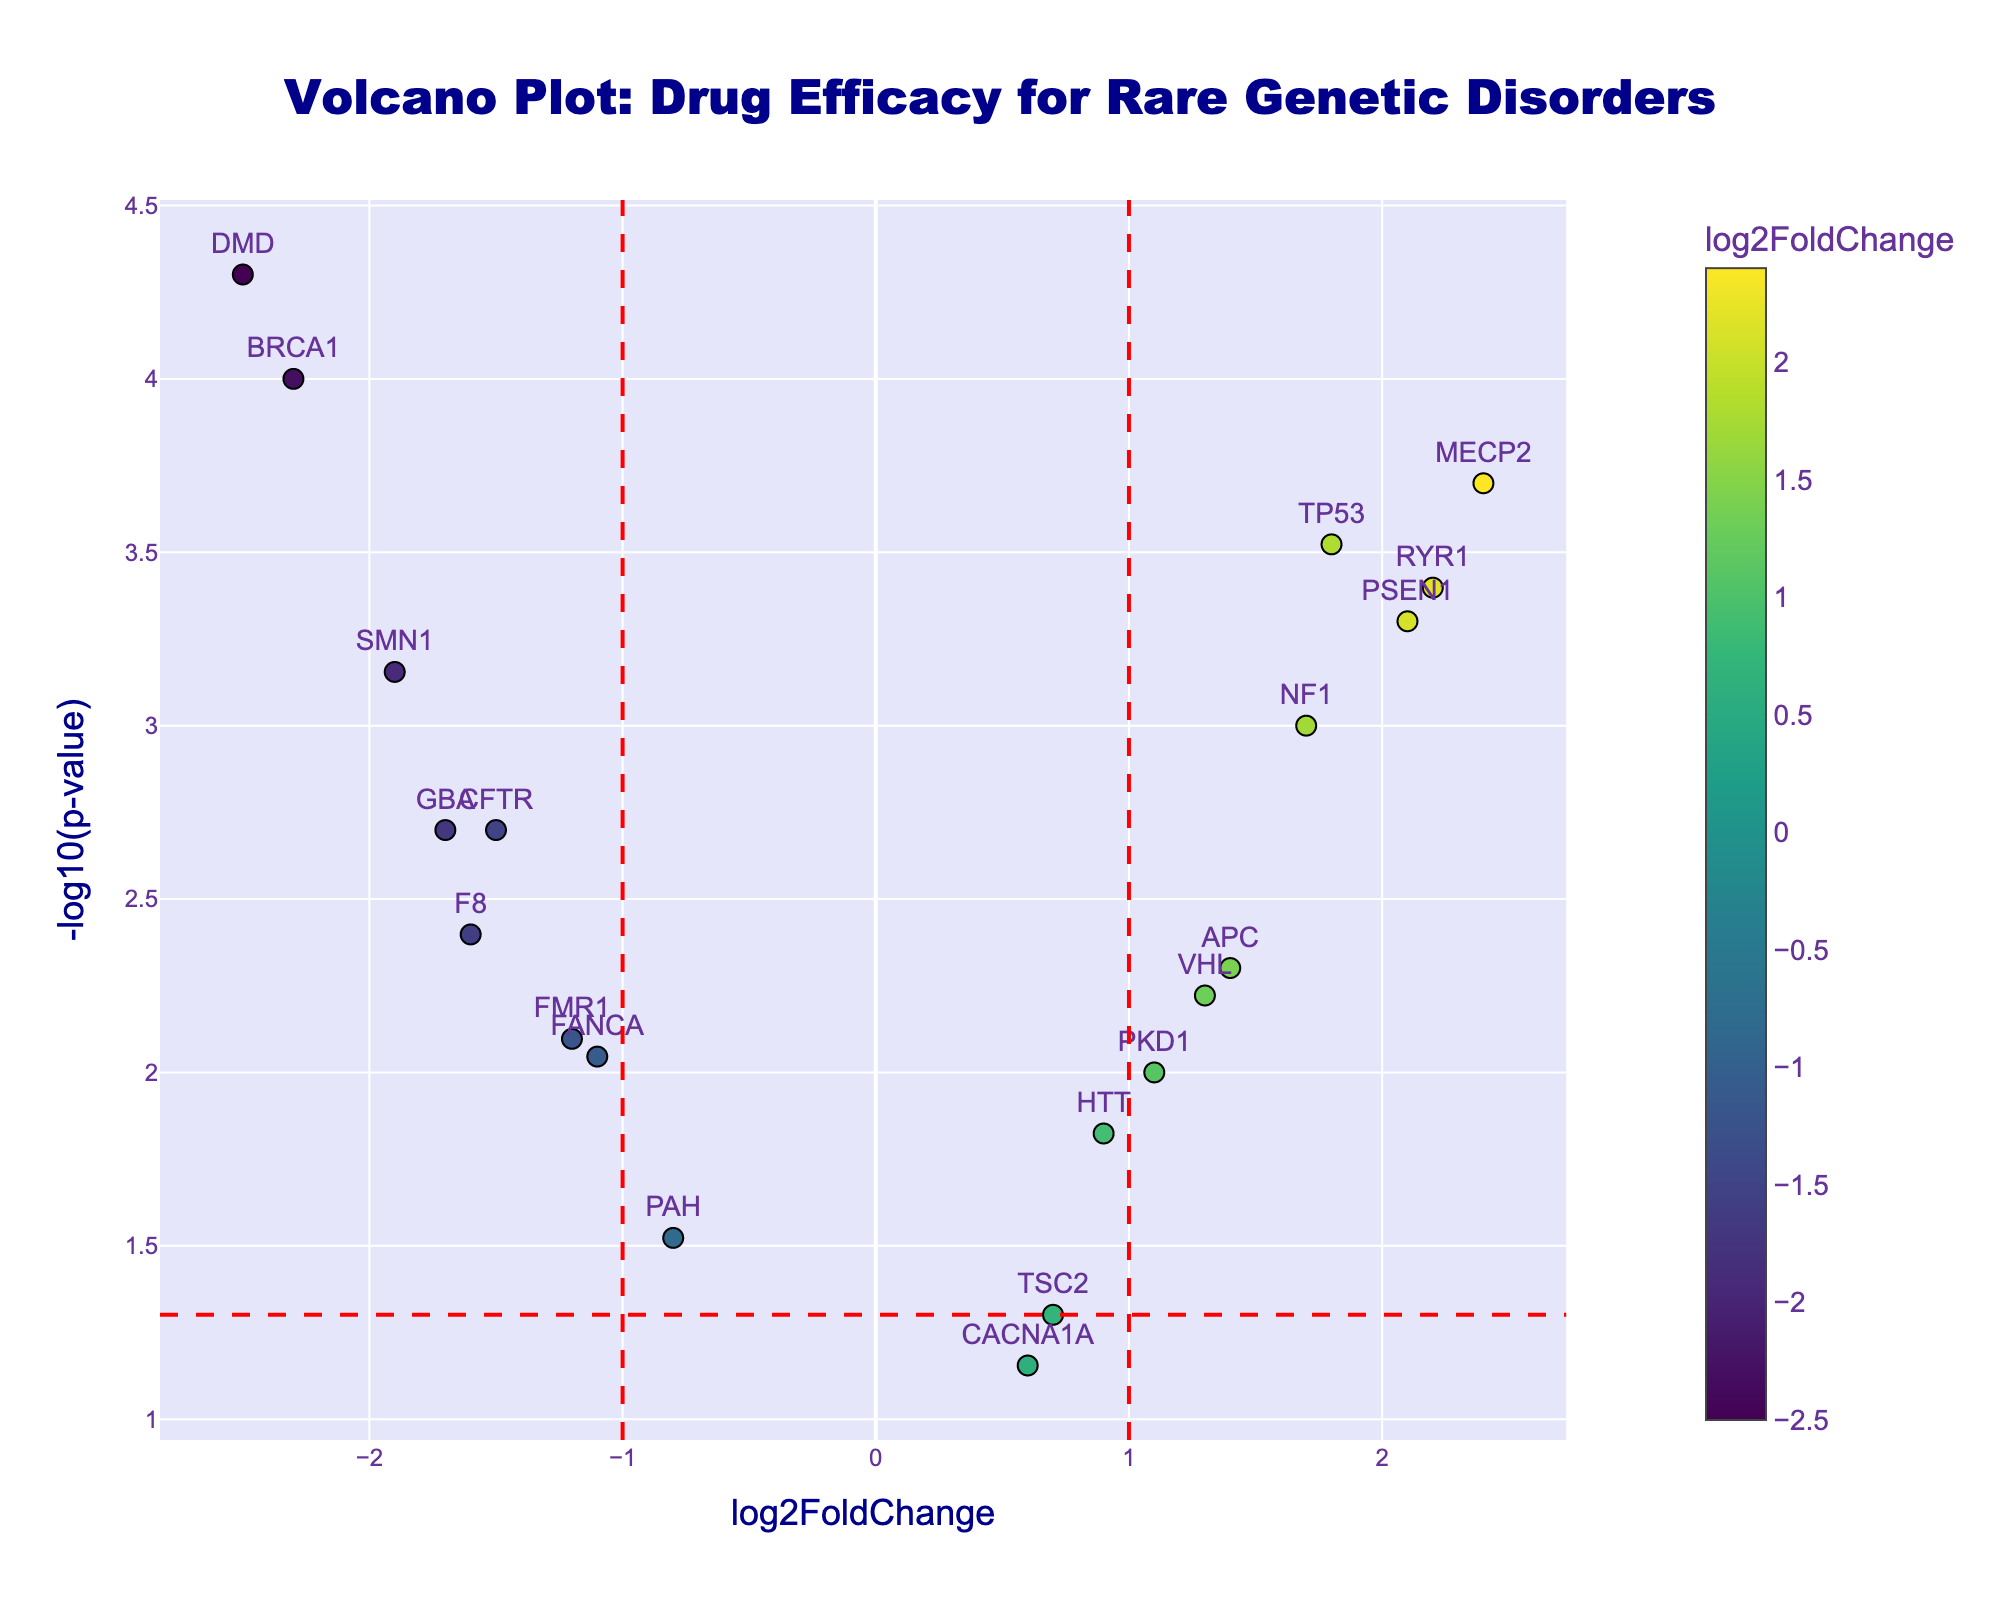What is the title of the plot? The title is typically found at the top of the plot in a larger font. For this plot, the title is centered at the top, and it reads "Volcano Plot: Drug Efficacy for Rare Genetic Disorders".
Answer: Volcano Plot: Drug Efficacy for Rare Genetic Disorders What is the x-axis representing? To understand what the x-axis represents, look at the label on the x-axis. In this plot, the x-axis label is "log2FoldChange", indicating it represents the log2-transformed fold change of drug efficacy.
Answer: log2FoldChange How many genes have a negative log2FoldChange? To determine how many genes have a negative log2FoldChange, count the data points on the left side of the y-axis (where log2FoldChange < 0). These genes include BRCA1, CFTR, FMR1, DMD, PAH, SMN1, F8, FANCA, and GBA.
Answer: 9 What is the y-axis value for the gene with the highest log2FoldChange? Locate the gene with the highest log2FoldChange on the x-axis, which is MECP2 with a log2FoldChange of 2.4. Then, check its corresponding y-axis value, which is -log10(p-value) calculated from the p-value (0.0002). -log10(0.0002) approximately equals 3.70.
Answer: 3.70 Which gene has the smallest p-value? The smallest p-value can be found by looking at the highest point on the y-axis, as -log10(p-value) will be the largest for the smallest p-value. The highest point corresponds to the gene DMD.
Answer: DMD How many genes are considered significantly different in their drug efficacy with a threshold of p-value < 0.05 and log2FoldChange >1 or < -1? Identify the genes that meet both criteria: p-value < 0.05, and log2FoldChange > 1 or < -1. This includes BRCA1, TP53, PSEN1, DMD, NF1, MECP2, SMN1, RYR1, and GBA.
Answer: 9 Which gene shows the highest negative log2FoldChange? The highest negative log2FoldChange is found by locating the leftmost point on the x-axis. This point corresponds to DMD with a log2FoldChange of -2.5.
Answer: DMD Which gene has the highest p-value, appearing closest to the x-axis? The gene with the highest p-value will be closest to the x-axis (smallest -log10(p-value)). CACNA1A has the highest p-value of 0.07.
Answer: CACNA1A Compare BRCA1 and PSEN1, which gene has more significant drug efficacy? By comparing the log2FoldChange and p-value of BRCA1 and PSEN1, BRCA1 has a log2FoldChange of -2.3 and a p-value of 0.0001, while PSEN1 has a log2FoldChange of 2.1 and a p-value of 0.0005. Since lower p-value and higher magnitude of log2FoldChange indicate more significant efficacy, BRCA1 is more significant.
Answer: BRCA1 